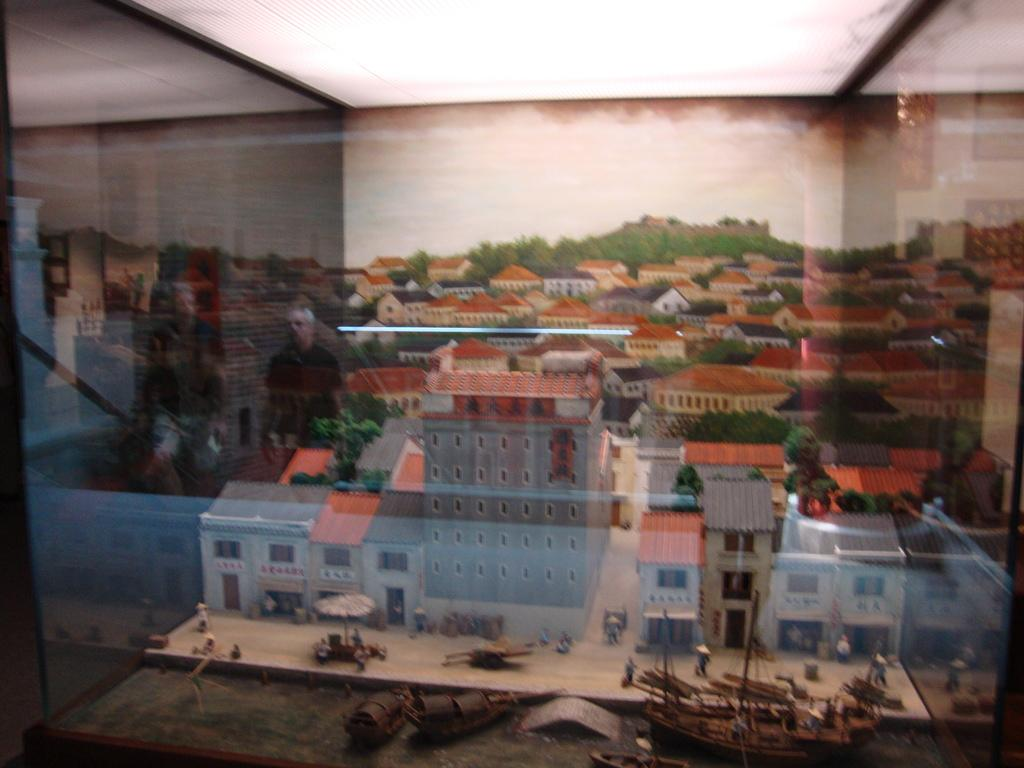What is inside the glass in the image? There is a miniature art in the glass. What can be seen in the miniature art? The miniature art contains buildings with roof-tiles and trees. Are there any other elements in the miniature art? Yes, there are ships and people at the bottom of the miniature art. What is the title of the book that the people are reading in the image? There is no book or reading activity depicted in the image; it features a miniature art scene with buildings, trees, ships, and people. 